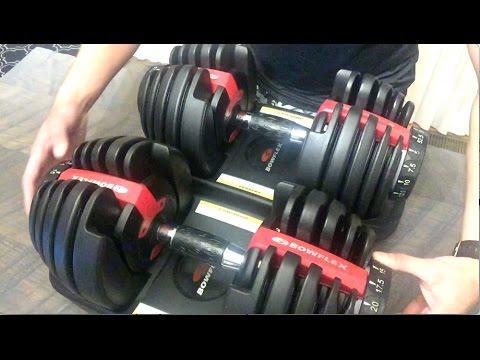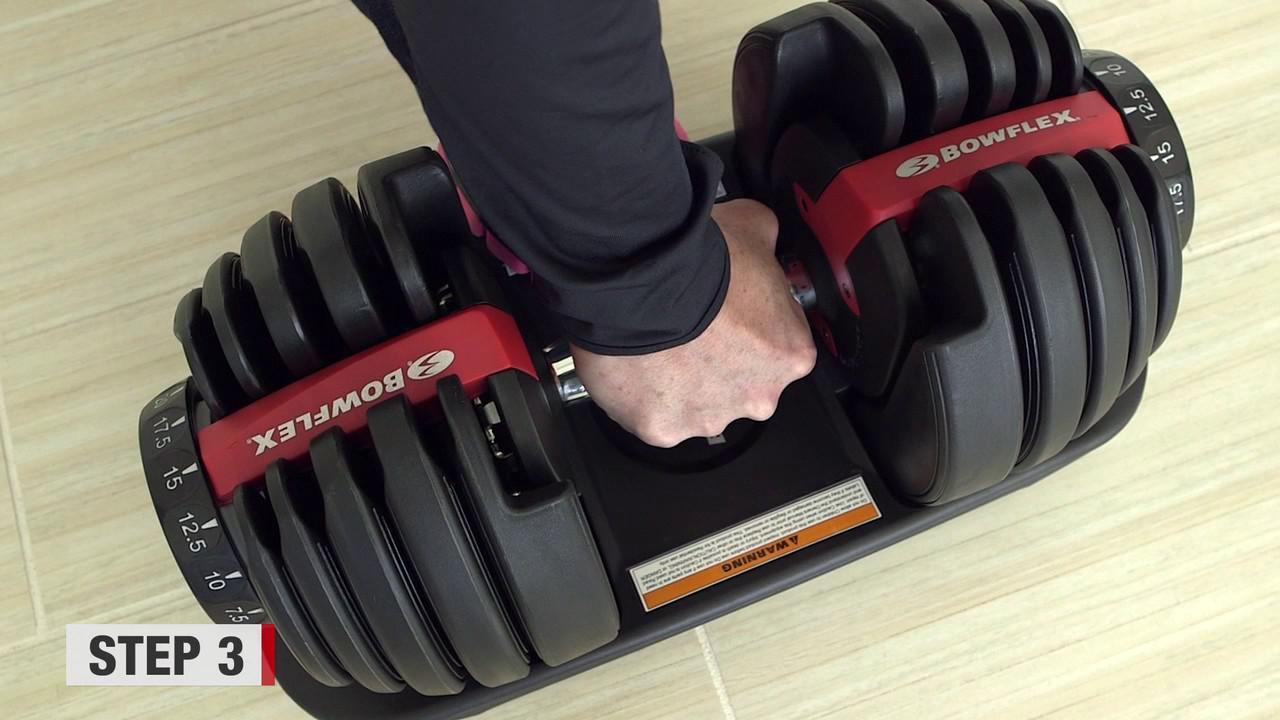The first image is the image on the left, the second image is the image on the right. Assess this claim about the two images: "There are three dumbbells.". Correct or not? Answer yes or no. Yes. The first image is the image on the left, the second image is the image on the right. Examine the images to the left and right. Is the description "There is exactly one hand visible." accurate? Answer yes or no. No. 